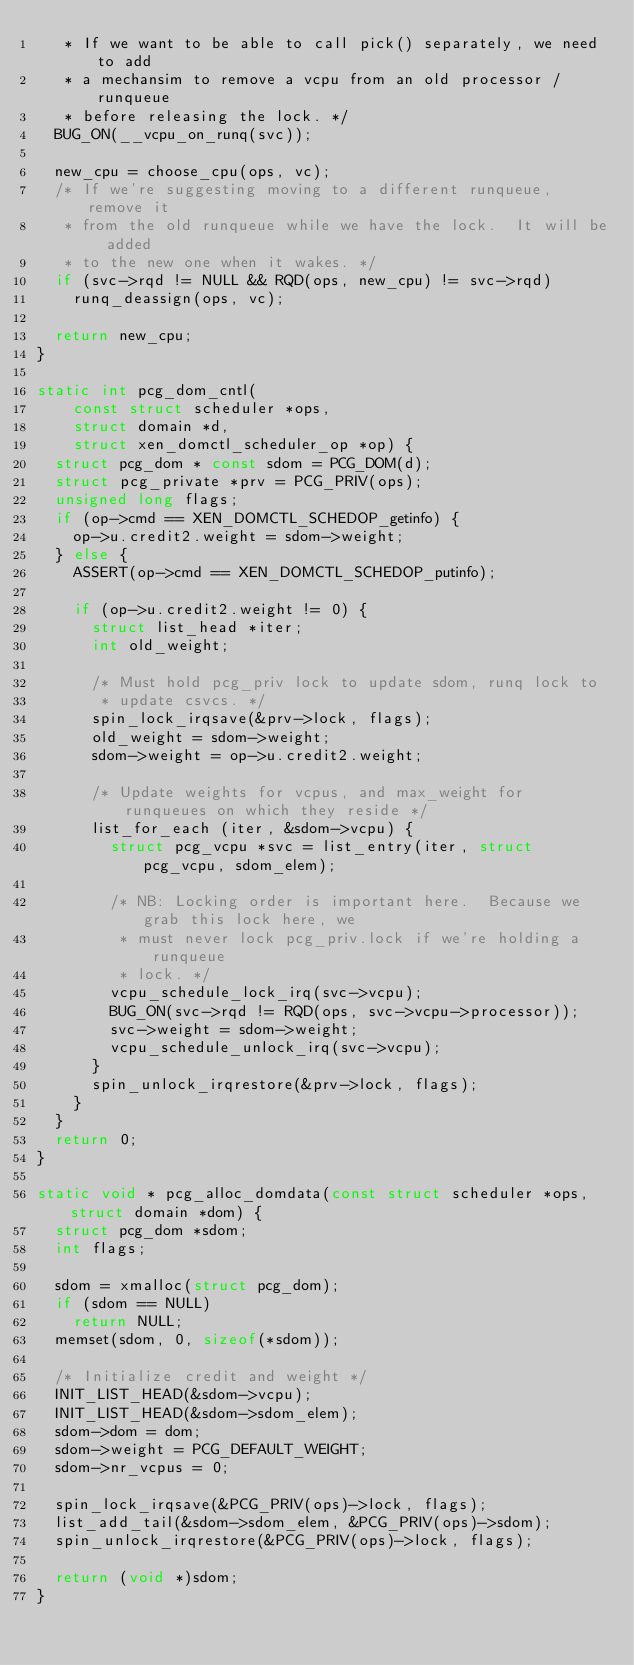<code> <loc_0><loc_0><loc_500><loc_500><_C_>   * If we want to be able to call pick() separately, we need to add
   * a mechansim to remove a vcpu from an old processor / runqueue
   * before releasing the lock. */
  BUG_ON(__vcpu_on_runq(svc));

  new_cpu = choose_cpu(ops, vc);
  /* If we're suggesting moving to a different runqueue, remove it
   * from the old runqueue while we have the lock.  It will be added
   * to the new one when it wakes. */
  if (svc->rqd != NULL && RQD(ops, new_cpu) != svc->rqd)
    runq_deassign(ops, vc);

  return new_cpu;
}

static int pcg_dom_cntl(
    const struct scheduler *ops,
    struct domain *d,
    struct xen_domctl_scheduler_op *op) {
  struct pcg_dom * const sdom = PCG_DOM(d);
  struct pcg_private *prv = PCG_PRIV(ops);
  unsigned long flags;
  if (op->cmd == XEN_DOMCTL_SCHEDOP_getinfo) {
    op->u.credit2.weight = sdom->weight;
  } else {
    ASSERT(op->cmd == XEN_DOMCTL_SCHEDOP_putinfo);

    if (op->u.credit2.weight != 0) {
      struct list_head *iter;
      int old_weight;

      /* Must hold pcg_priv lock to update sdom, runq lock to
       * update csvcs. */
      spin_lock_irqsave(&prv->lock, flags);
      old_weight = sdom->weight;
      sdom->weight = op->u.credit2.weight;

      /* Update weights for vcpus, and max_weight for runqueues on which they reside */
      list_for_each (iter, &sdom->vcpu) {
        struct pcg_vcpu *svc = list_entry(iter, struct pcg_vcpu, sdom_elem);

        /* NB: Locking order is important here.  Because we grab this lock here, we
         * must never lock pcg_priv.lock if we're holding a runqueue
         * lock. */
        vcpu_schedule_lock_irq(svc->vcpu);
        BUG_ON(svc->rqd != RQD(ops, svc->vcpu->processor));
        svc->weight = sdom->weight;
        vcpu_schedule_unlock_irq(svc->vcpu);
      }
      spin_unlock_irqrestore(&prv->lock, flags);
    }
  }
  return 0;
}

static void * pcg_alloc_domdata(const struct scheduler *ops, struct domain *dom) {
  struct pcg_dom *sdom;
  int flags;

  sdom = xmalloc(struct pcg_dom);
  if (sdom == NULL)
    return NULL;
  memset(sdom, 0, sizeof(*sdom));

  /* Initialize credit and weight */
  INIT_LIST_HEAD(&sdom->vcpu);
  INIT_LIST_HEAD(&sdom->sdom_elem);
  sdom->dom = dom;
  sdom->weight = PCG_DEFAULT_WEIGHT;
  sdom->nr_vcpus = 0;

  spin_lock_irqsave(&PCG_PRIV(ops)->lock, flags);
  list_add_tail(&sdom->sdom_elem, &PCG_PRIV(ops)->sdom);
  spin_unlock_irqrestore(&PCG_PRIV(ops)->lock, flags);

  return (void *)sdom;
}</code> 